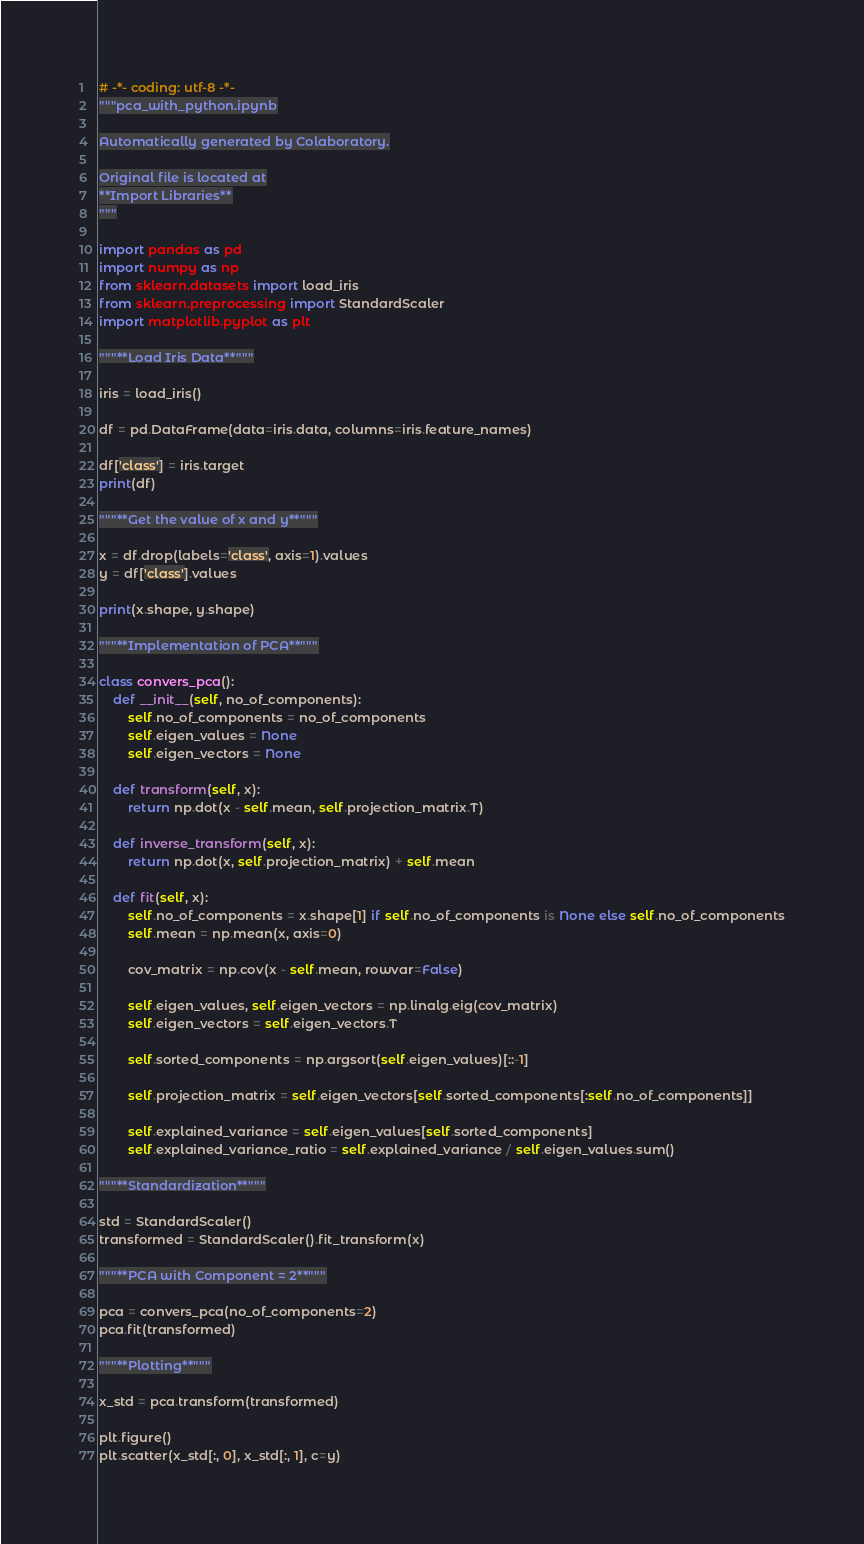<code> <loc_0><loc_0><loc_500><loc_500><_Python_># -*- coding: utf-8 -*-
"""pca_with_python.ipynb

Automatically generated by Colaboratory.

Original file is located at
**Import Libraries**
"""

import pandas as pd
import numpy as np
from sklearn.datasets import load_iris
from sklearn.preprocessing import StandardScaler
import matplotlib.pyplot as plt

"""**Load Iris Data**"""

iris = load_iris()

df = pd.DataFrame(data=iris.data, columns=iris.feature_names)

df['class'] = iris.target
print(df)

"""**Get the value of x and y**"""

x = df.drop(labels='class', axis=1).values
y = df['class'].values

print(x.shape, y.shape)

"""**Implementation of PCA**"""

class convers_pca():
    def __init__(self, no_of_components):
        self.no_of_components = no_of_components
        self.eigen_values = None
        self.eigen_vectors = None
        
    def transform(self, x):
        return np.dot(x - self.mean, self.projection_matrix.T)
    
    def inverse_transform(self, x):
        return np.dot(x, self.projection_matrix) + self.mean
    
    def fit(self, x):
        self.no_of_components = x.shape[1] if self.no_of_components is None else self.no_of_components
        self.mean = np.mean(x, axis=0)
        
        cov_matrix = np.cov(x - self.mean, rowvar=False)
        
        self.eigen_values, self.eigen_vectors = np.linalg.eig(cov_matrix)
        self.eigen_vectors = self.eigen_vectors.T
        
        self.sorted_components = np.argsort(self.eigen_values)[::-1]
        
        self.projection_matrix = self.eigen_vectors[self.sorted_components[:self.no_of_components]]

        self.explained_variance = self.eigen_values[self.sorted_components]
        self.explained_variance_ratio = self.explained_variance / self.eigen_values.sum()

"""**Standardization**"""

std = StandardScaler()
transformed = StandardScaler().fit_transform(x)

"""**PCA with Component = 2**"""

pca = convers_pca(no_of_components=2)
pca.fit(transformed)

"""**Plotting**"""

x_std = pca.transform(transformed)

plt.figure()
plt.scatter(x_std[:, 0], x_std[:, 1], c=y)</code> 